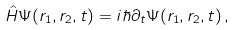<formula> <loc_0><loc_0><loc_500><loc_500>\hat { H } \Psi ( { r } _ { 1 } , { r } _ { 2 } , t ) = i \hbar { \partial } _ { t } \Psi ( { r } _ { 1 } , { r } _ { 2 } , t ) \, ,</formula> 